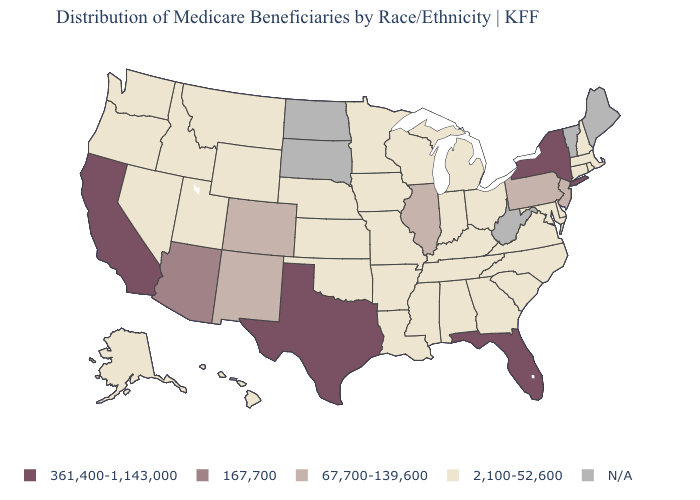Name the states that have a value in the range 361,400-1,143,000?
Write a very short answer. California, Florida, New York, Texas. Name the states that have a value in the range 361,400-1,143,000?
Be succinct. California, Florida, New York, Texas. What is the value of Oregon?
Concise answer only. 2,100-52,600. Name the states that have a value in the range 2,100-52,600?
Give a very brief answer. Alabama, Alaska, Arkansas, Connecticut, Delaware, Georgia, Hawaii, Idaho, Indiana, Iowa, Kansas, Kentucky, Louisiana, Maryland, Massachusetts, Michigan, Minnesota, Mississippi, Missouri, Montana, Nebraska, Nevada, New Hampshire, North Carolina, Ohio, Oklahoma, Oregon, Rhode Island, South Carolina, Tennessee, Utah, Virginia, Washington, Wisconsin, Wyoming. What is the value of Massachusetts?
Short answer required. 2,100-52,600. What is the highest value in the USA?
Short answer required. 361,400-1,143,000. What is the lowest value in the USA?
Short answer required. 2,100-52,600. Does Texas have the highest value in the South?
Answer briefly. Yes. What is the highest value in states that border Maryland?
Keep it brief. 67,700-139,600. What is the value of West Virginia?
Answer briefly. N/A. What is the highest value in states that border Missouri?
Write a very short answer. 67,700-139,600. Which states have the lowest value in the Northeast?
Answer briefly. Connecticut, Massachusetts, New Hampshire, Rhode Island. Name the states that have a value in the range N/A?
Quick response, please. Maine, North Dakota, South Dakota, Vermont, West Virginia. 